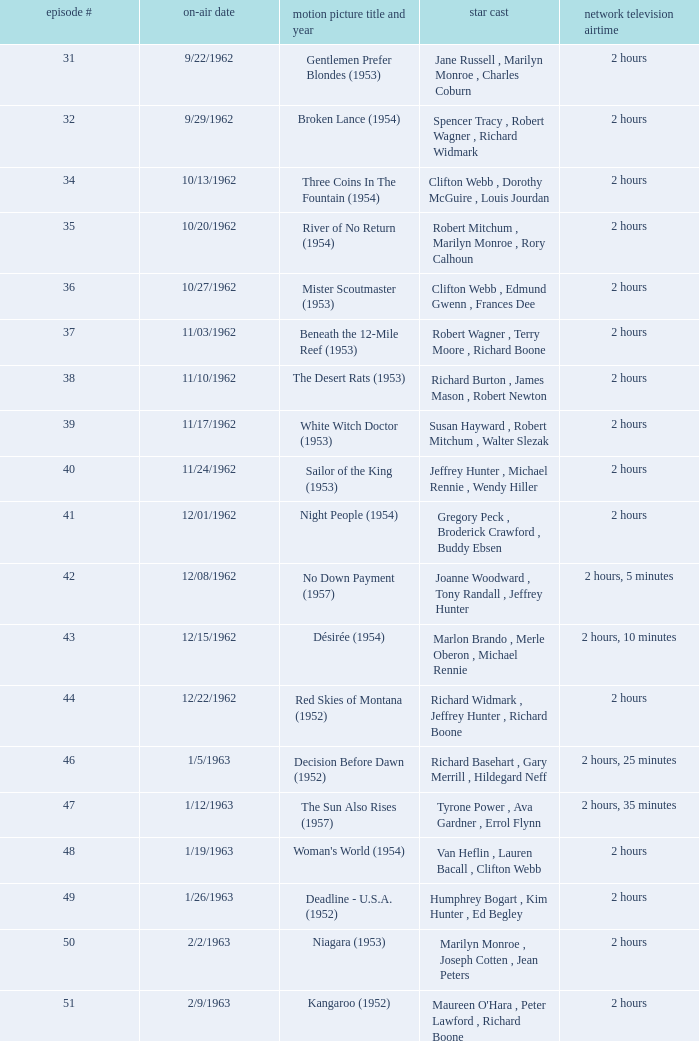What movie did dana wynter , mel ferrer , theodore bikel star in? Fraulein (1958). 